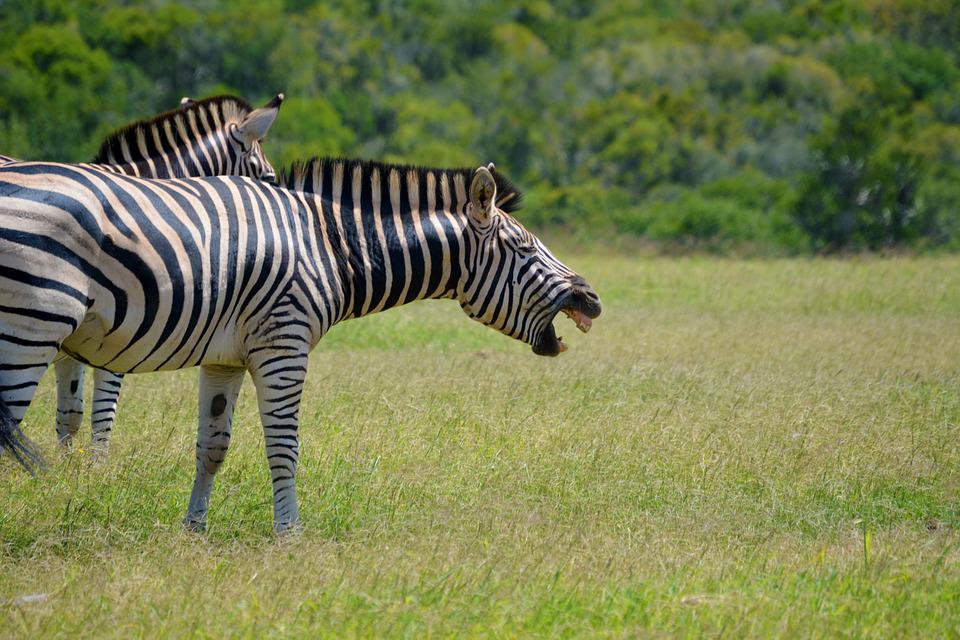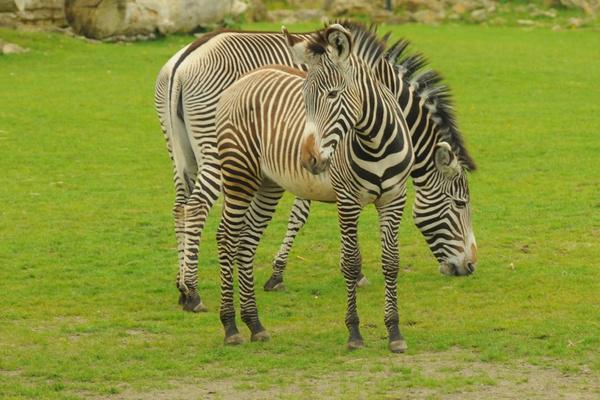The first image is the image on the left, the second image is the image on the right. Evaluate the accuracy of this statement regarding the images: "The left image contains exactly two zebras.". Is it true? Answer yes or no. Yes. The first image is the image on the left, the second image is the image on the right. For the images displayed, is the sentence "No more than three zebra are shown in total, and the right image contains a single zebra standing with its head and body in profile." factually correct? Answer yes or no. No. 